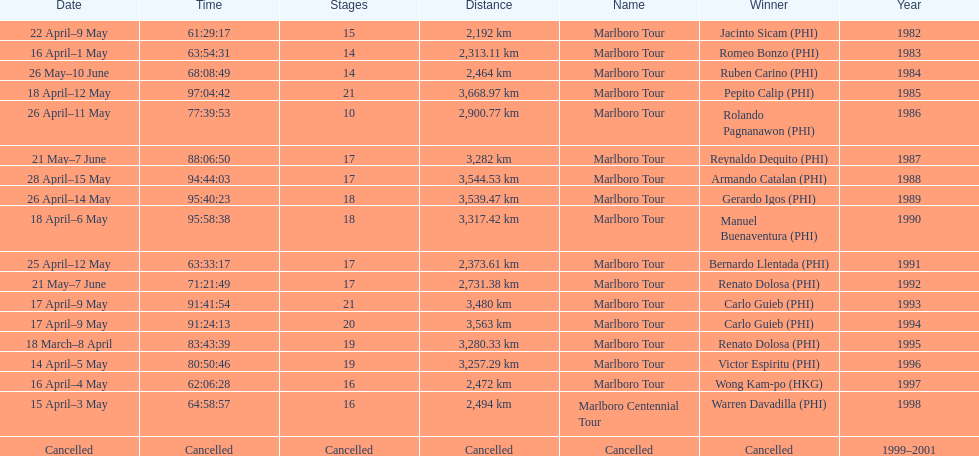How many stages was the 1982 marlboro tour? 15. 